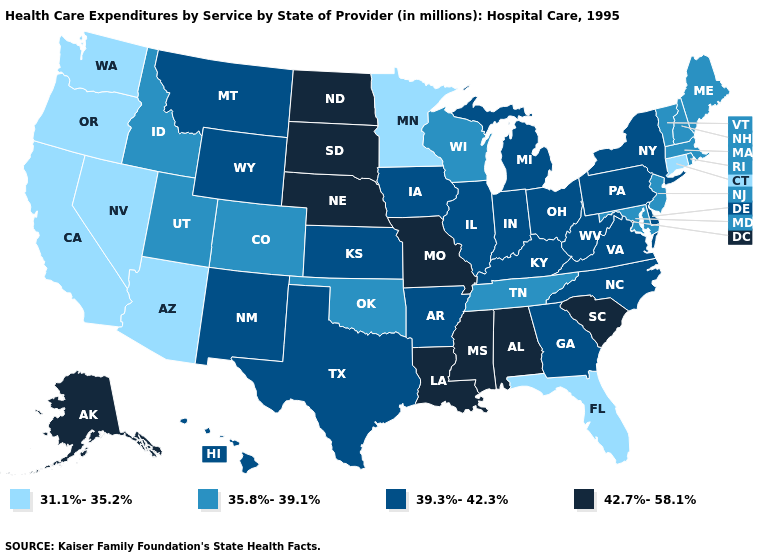What is the value of Maryland?
Be succinct. 35.8%-39.1%. Among the states that border South Dakota , does Wyoming have the highest value?
Short answer required. No. Does Connecticut have the lowest value in the Northeast?
Quick response, please. Yes. Which states have the lowest value in the USA?
Concise answer only. Arizona, California, Connecticut, Florida, Minnesota, Nevada, Oregon, Washington. Name the states that have a value in the range 31.1%-35.2%?
Quick response, please. Arizona, California, Connecticut, Florida, Minnesota, Nevada, Oregon, Washington. What is the value of Texas?
Answer briefly. 39.3%-42.3%. Does Arkansas have a higher value than Hawaii?
Write a very short answer. No. What is the value of North Dakota?
Short answer required. 42.7%-58.1%. Among the states that border Rhode Island , does Massachusetts have the lowest value?
Quick response, please. No. Which states have the highest value in the USA?
Be succinct. Alabama, Alaska, Louisiana, Mississippi, Missouri, Nebraska, North Dakota, South Carolina, South Dakota. What is the value of Kansas?
Short answer required. 39.3%-42.3%. Name the states that have a value in the range 31.1%-35.2%?
Keep it brief. Arizona, California, Connecticut, Florida, Minnesota, Nevada, Oregon, Washington. Name the states that have a value in the range 31.1%-35.2%?
Answer briefly. Arizona, California, Connecticut, Florida, Minnesota, Nevada, Oregon, Washington. What is the value of New Jersey?
Short answer required. 35.8%-39.1%. What is the lowest value in the USA?
Concise answer only. 31.1%-35.2%. 